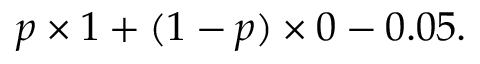<formula> <loc_0><loc_0><loc_500><loc_500>p \times 1 + ( 1 - p ) \times 0 - 0 . 0 5 .</formula> 